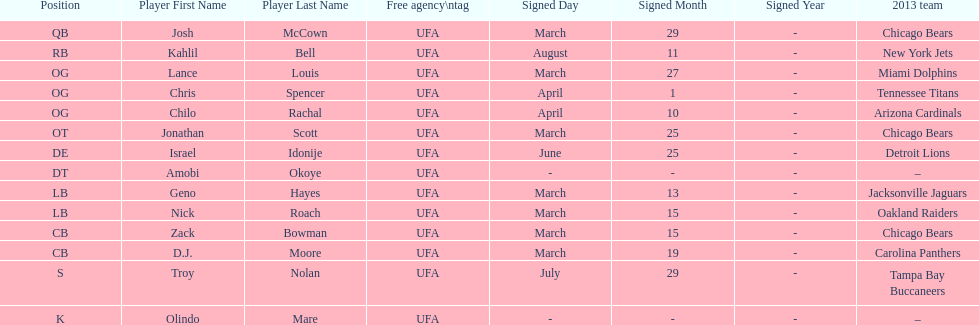How many players were signed in march? 7. 